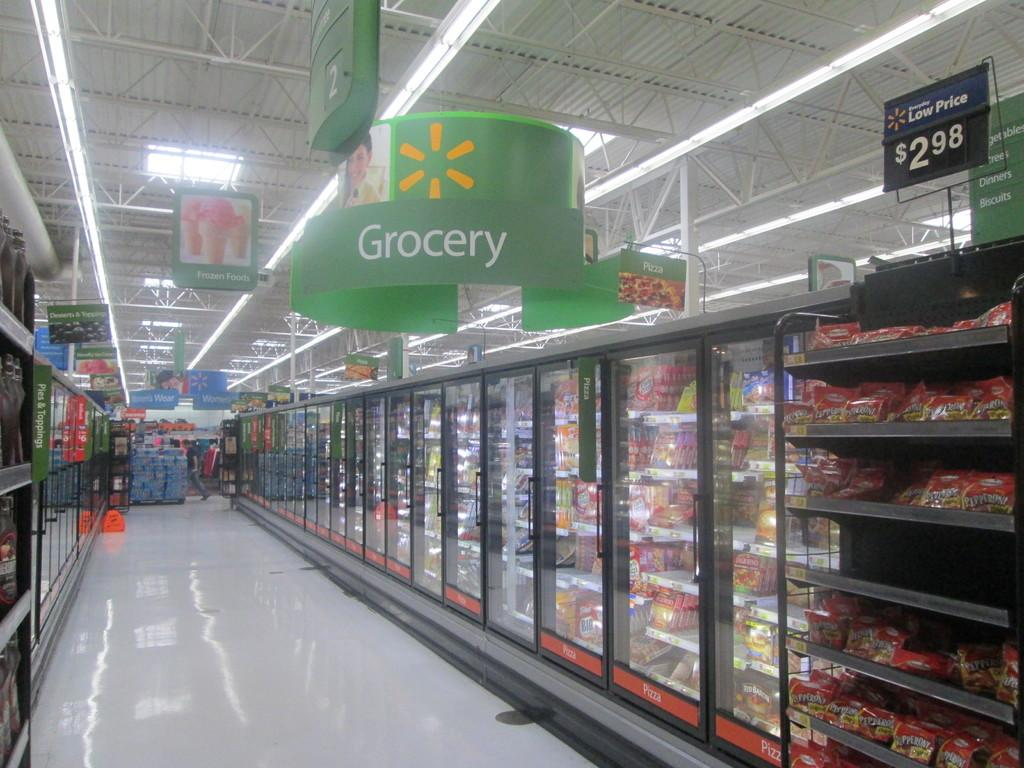Provide a one-sentence caption for the provided image. store with refrigerated isle that has green sign at top that has grocery on it and rack toward front with price of 2.98 at top of it. 